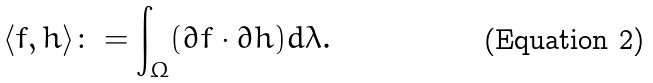<formula> <loc_0><loc_0><loc_500><loc_500>\langle f , h \rangle \colon = \int _ { \Omega } ( \partial f \cdot \partial h ) d \lambda .</formula> 